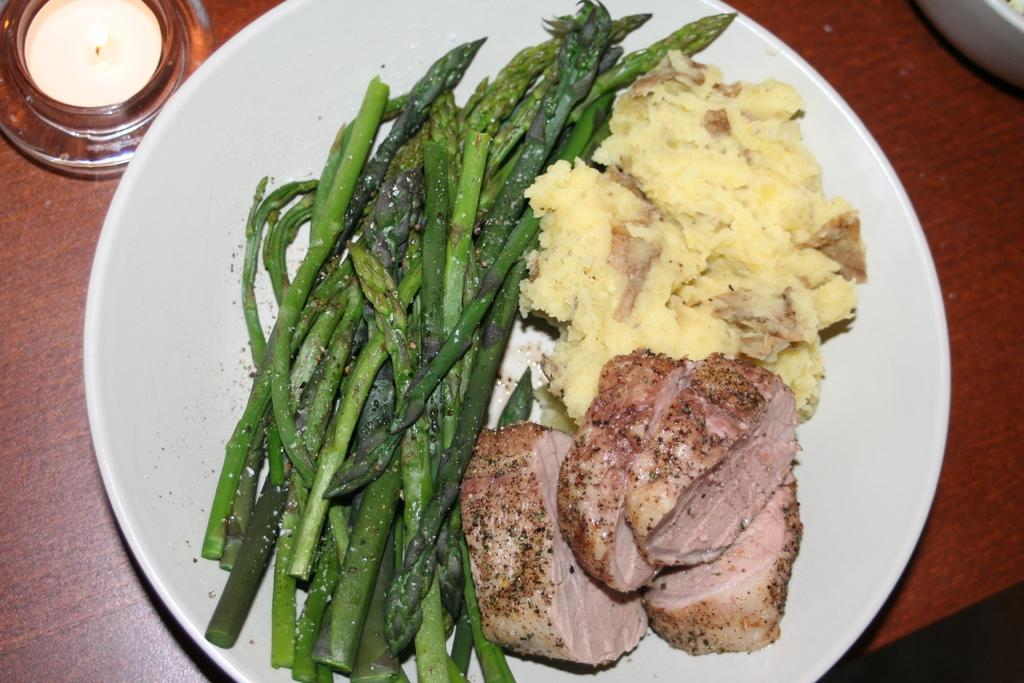What is on the plate that is visible in the image? There is a plate with food in the image. What other object can be seen in the image besides the plate with food? There is a lid and a bowl visible in the image. Where are all the objects located in the image? All objects are on a table. What type of roof can be seen on the table in the image? There is no roof present in the image; it is a table with objects on it. Can you tell me how many nests are visible on the plate with food? There are no nests visible on the plate with food; it contains food items. 